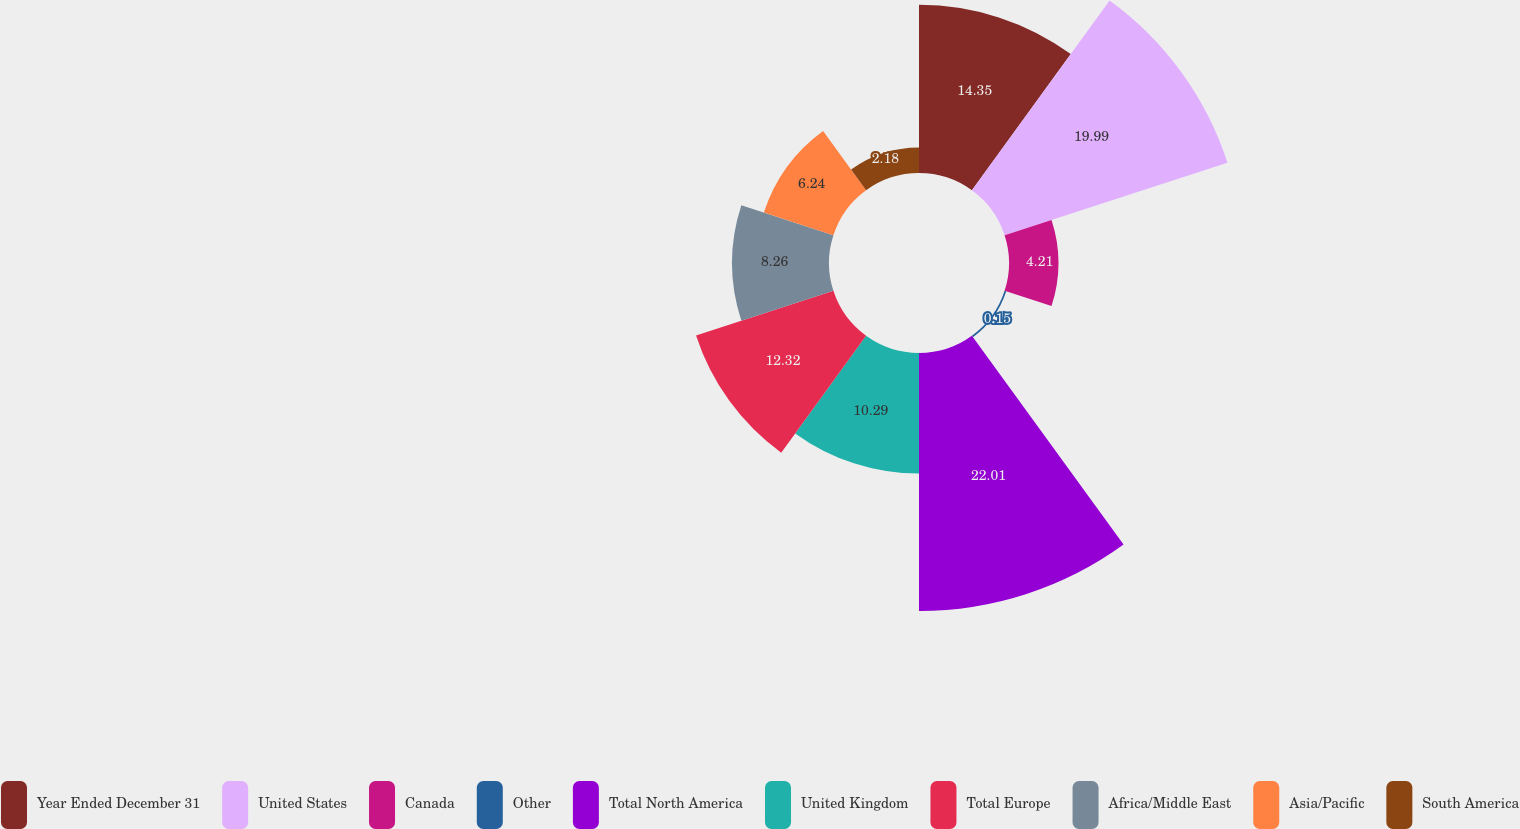Convert chart. <chart><loc_0><loc_0><loc_500><loc_500><pie_chart><fcel>Year Ended December 31<fcel>United States<fcel>Canada<fcel>Other<fcel>Total North America<fcel>United Kingdom<fcel>Total Europe<fcel>Africa/Middle East<fcel>Asia/Pacific<fcel>South America<nl><fcel>14.35%<fcel>19.99%<fcel>4.21%<fcel>0.15%<fcel>22.01%<fcel>10.29%<fcel>12.32%<fcel>8.26%<fcel>6.24%<fcel>2.18%<nl></chart> 